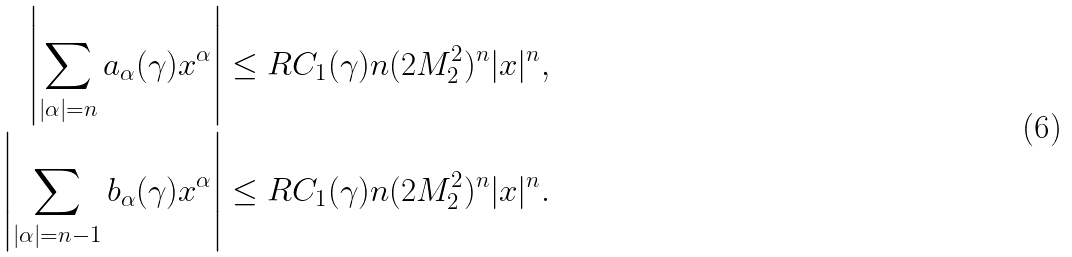<formula> <loc_0><loc_0><loc_500><loc_500>\left | \sum _ { | \alpha | = n } a _ { \alpha } ( \gamma ) x ^ { \alpha } \right | \leq R C _ { 1 } ( \gamma ) n ( 2 M _ { 2 } ^ { 2 } ) ^ { n } | x | ^ { n } , \\ \left | \sum _ { | \alpha | = n - 1 } b _ { \alpha } ( \gamma ) x ^ { \alpha } \right | \leq R C _ { 1 } ( \gamma ) n ( 2 M _ { 2 } ^ { 2 } ) ^ { n } | x | ^ { n } .</formula> 